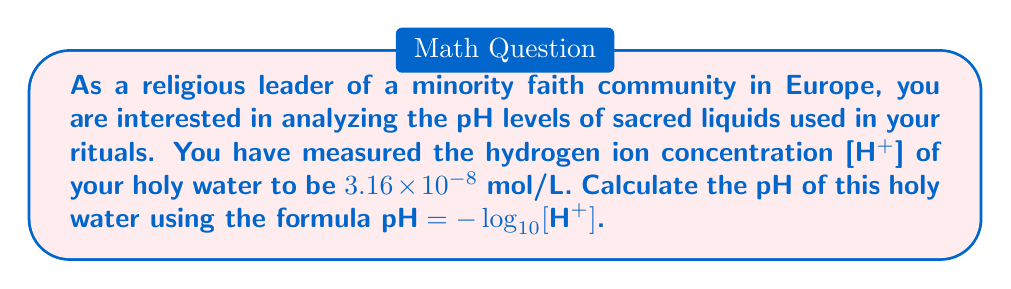Can you answer this question? To solve this problem, we need to use the given formula: $pH = -\log_{10}[H^+]$

Given:
[H+] = $3.16 \times 10^{-8}$ mol/L

Step 1: Substitute the given [H+] concentration into the pH formula.
$pH = -\log_{10}(3.16 \times 10^{-8})$

Step 2: Use the properties of logarithms to simplify the calculation.
$\log_{10}(a \times 10^n) = \log_{10}(a) + n$, where $a$ is a number between 1 and 10.

In this case, $3.16 = 10^{0.5}$, so we can rewrite the expression as:
$pH = -\log_{10}(10^{0.5} \times 10^{-8})$
$pH = -(\log_{10}(10^{0.5}) + \log_{10}(10^{-8}))$
$pH = -(0.5 - 8)$
$pH = -(-7.5)$
$pH = 7.5$

Therefore, the pH of the holy water is 7.5.
Answer: $pH = 7.5$ 